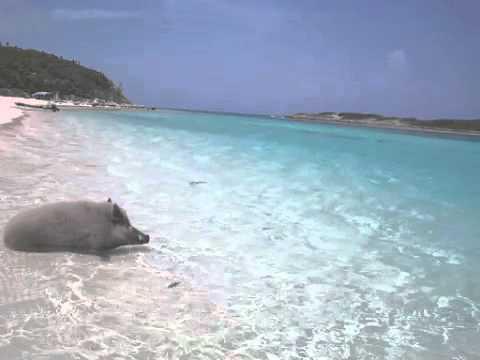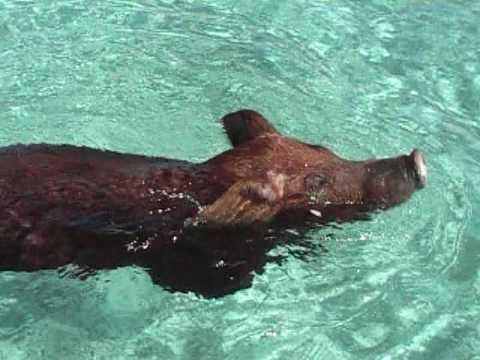The first image is the image on the left, the second image is the image on the right. Evaluate the accuracy of this statement regarding the images: "At least one pig is swimming through the water.". Is it true? Answer yes or no. Yes. The first image is the image on the left, the second image is the image on the right. For the images displayed, is the sentence "Left image shows one wild hog that is lying in shallow water at the shoreline." factually correct? Answer yes or no. Yes. 